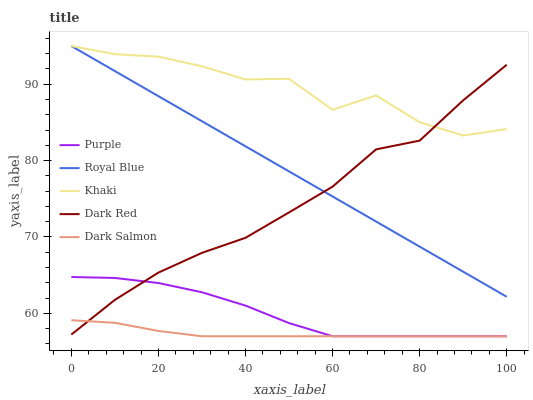Does Dark Salmon have the minimum area under the curve?
Answer yes or no. Yes. Does Khaki have the maximum area under the curve?
Answer yes or no. Yes. Does Royal Blue have the minimum area under the curve?
Answer yes or no. No. Does Royal Blue have the maximum area under the curve?
Answer yes or no. No. Is Royal Blue the smoothest?
Answer yes or no. Yes. Is Khaki the roughest?
Answer yes or no. Yes. Is Khaki the smoothest?
Answer yes or no. No. Is Royal Blue the roughest?
Answer yes or no. No. Does Purple have the lowest value?
Answer yes or no. Yes. Does Royal Blue have the lowest value?
Answer yes or no. No. Does Khaki have the highest value?
Answer yes or no. Yes. Does Dark Salmon have the highest value?
Answer yes or no. No. Is Purple less than Khaki?
Answer yes or no. Yes. Is Khaki greater than Dark Salmon?
Answer yes or no. Yes. Does Purple intersect Dark Salmon?
Answer yes or no. Yes. Is Purple less than Dark Salmon?
Answer yes or no. No. Is Purple greater than Dark Salmon?
Answer yes or no. No. Does Purple intersect Khaki?
Answer yes or no. No. 